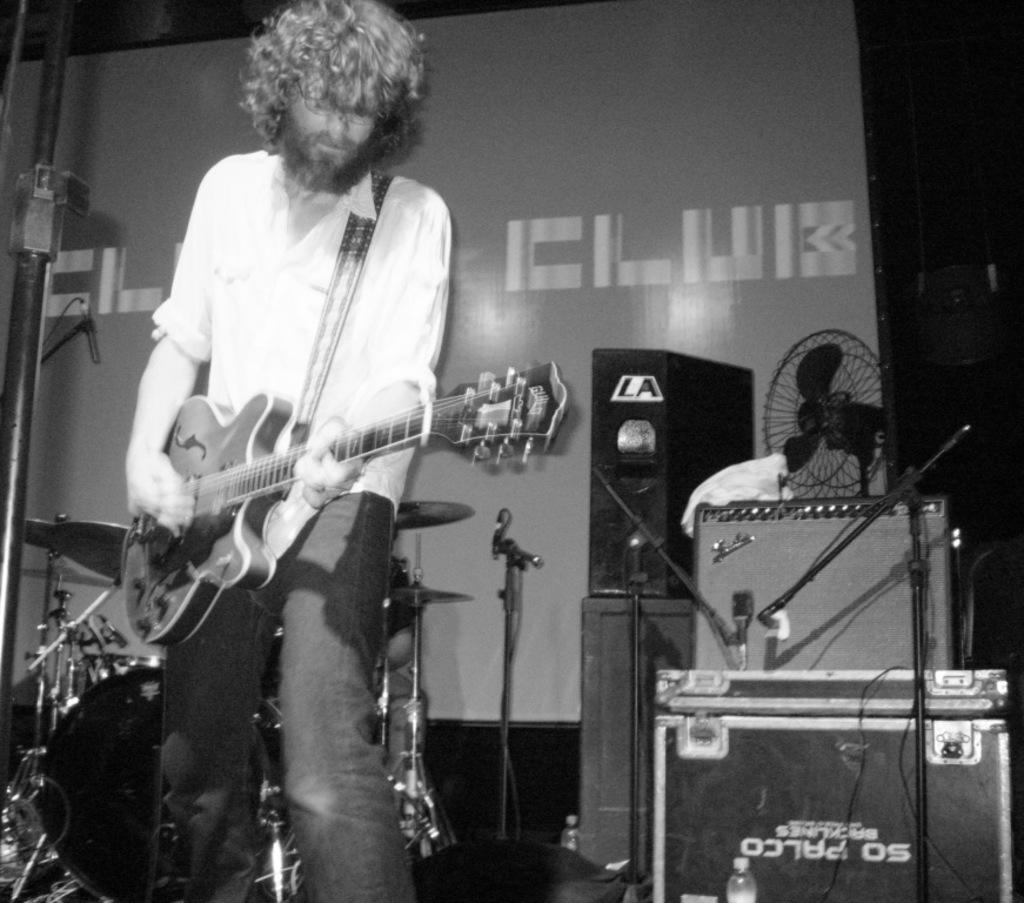What is the main subject of the image? There is a person standing in the image. What is the person doing in the image? The person is playing a musical instrument. What type of zipper can be seen on the person's clothing in the image? There is no zipper visible on the person's clothing in the image. What kind of structure is present in the background of the image? There is no structure mentioned in the provided facts, so we cannot determine if there is one in the background. 